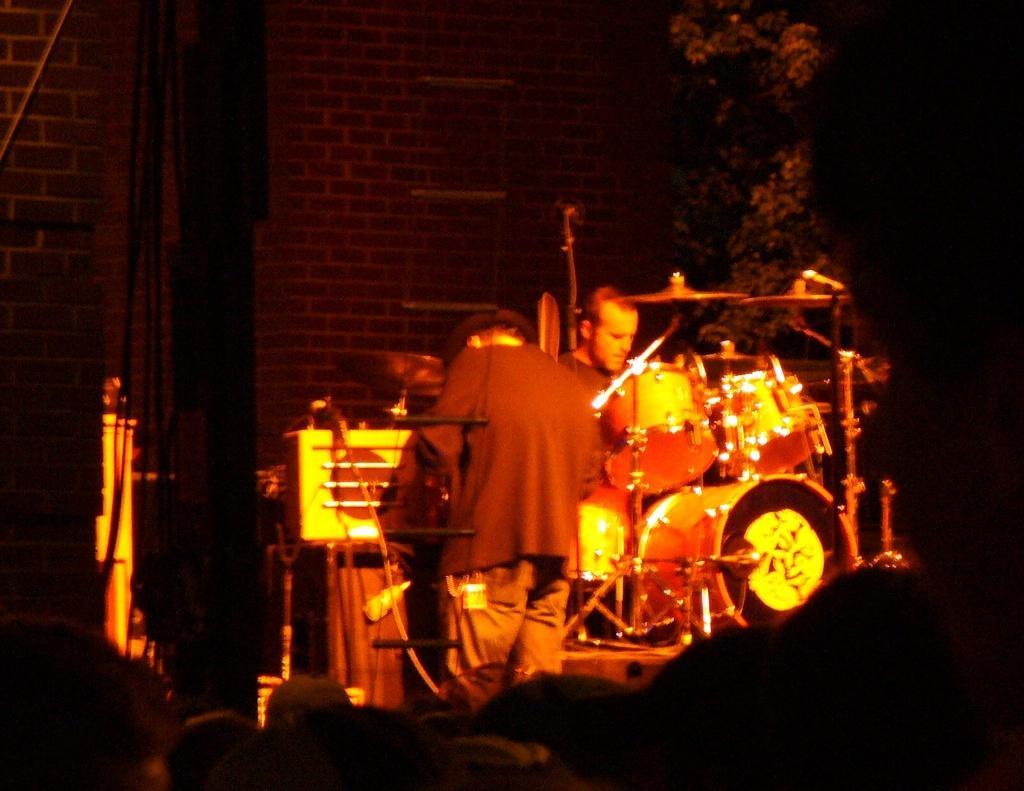Could you give a brief overview of what you see in this image? In this picture we can see there are two people on the stage. In front of the people there are music instruments, tree and a wall. 